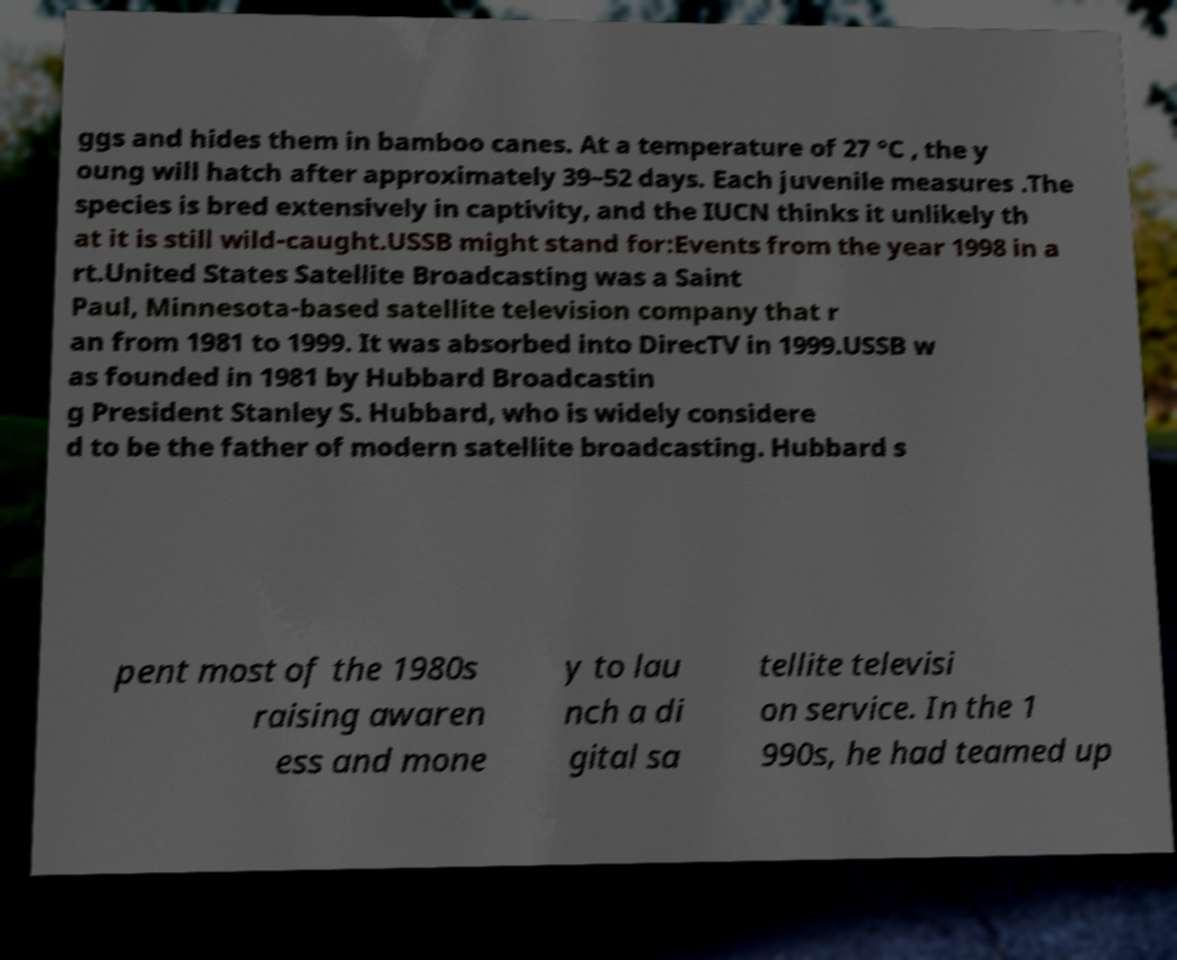For documentation purposes, I need the text within this image transcribed. Could you provide that? ggs and hides them in bamboo canes. At a temperature of 27 °C , the y oung will hatch after approximately 39–52 days. Each juvenile measures .The species is bred extensively in captivity, and the IUCN thinks it unlikely th at it is still wild-caught.USSB might stand for:Events from the year 1998 in a rt.United States Satellite Broadcasting was a Saint Paul, Minnesota-based satellite television company that r an from 1981 to 1999. It was absorbed into DirecTV in 1999.USSB w as founded in 1981 by Hubbard Broadcastin g President Stanley S. Hubbard, who is widely considere d to be the father of modern satellite broadcasting. Hubbard s pent most of the 1980s raising awaren ess and mone y to lau nch a di gital sa tellite televisi on service. In the 1 990s, he had teamed up 